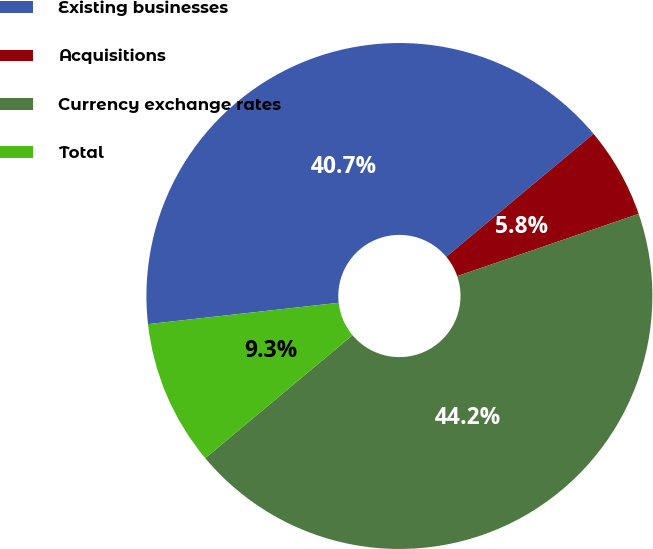Convert chart. <chart><loc_0><loc_0><loc_500><loc_500><pie_chart><fcel>Existing businesses<fcel>Acquisitions<fcel>Currency exchange rates<fcel>Total<nl><fcel>40.7%<fcel>5.81%<fcel>44.19%<fcel>9.3%<nl></chart> 